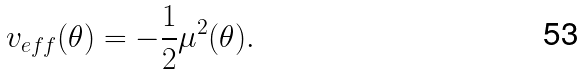<formula> <loc_0><loc_0><loc_500><loc_500>v _ { e f f } ( \theta ) = - \frac { 1 } { 2 } \mu ^ { 2 } ( \theta ) .</formula> 